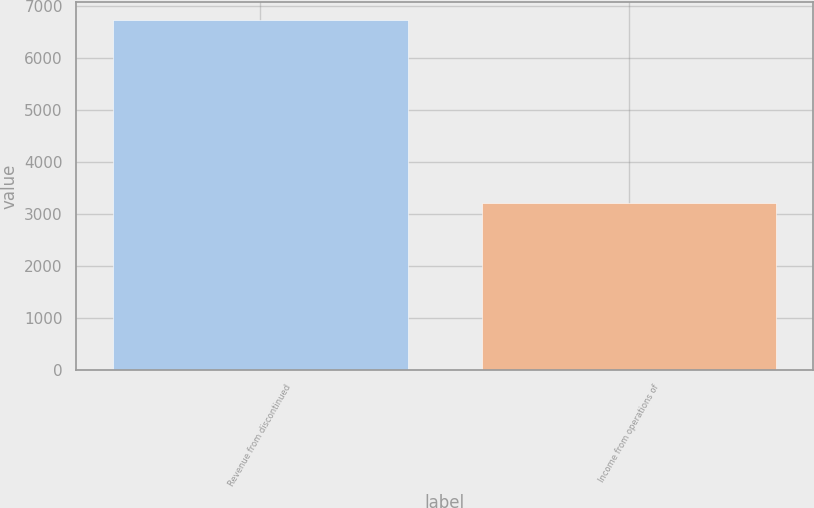Convert chart to OTSL. <chart><loc_0><loc_0><loc_500><loc_500><bar_chart><fcel>Revenue from discontinued<fcel>Income from operations of<nl><fcel>6745<fcel>3208<nl></chart> 